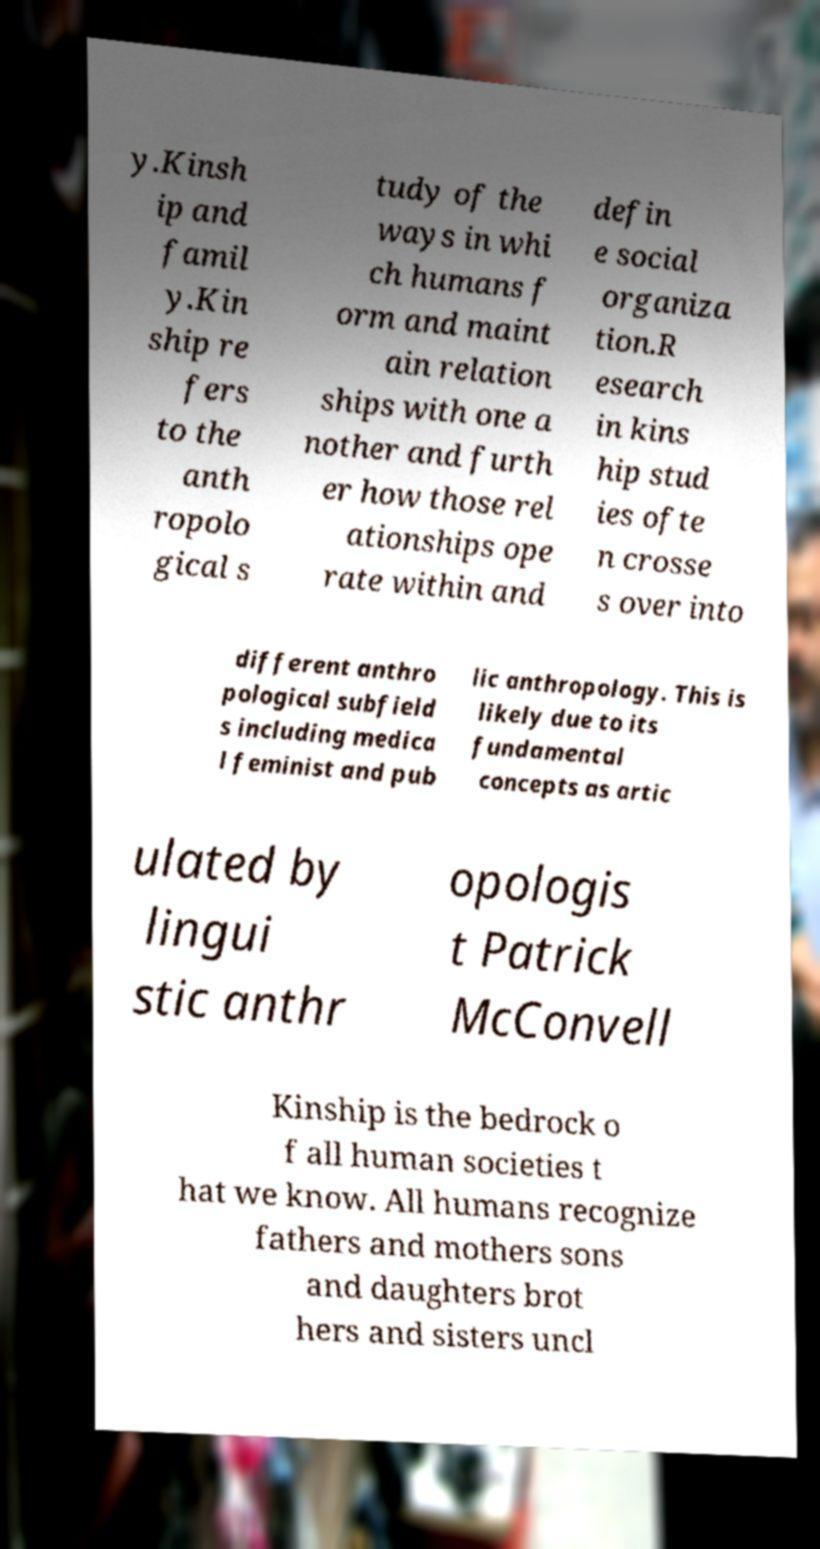There's text embedded in this image that I need extracted. Can you transcribe it verbatim? y.Kinsh ip and famil y.Kin ship re fers to the anth ropolo gical s tudy of the ways in whi ch humans f orm and maint ain relation ships with one a nother and furth er how those rel ationships ope rate within and defin e social organiza tion.R esearch in kins hip stud ies ofte n crosse s over into different anthro pological subfield s including medica l feminist and pub lic anthropology. This is likely due to its fundamental concepts as artic ulated by lingui stic anthr opologis t Patrick McConvell Kinship is the bedrock o f all human societies t hat we know. All humans recognize fathers and mothers sons and daughters brot hers and sisters uncl 